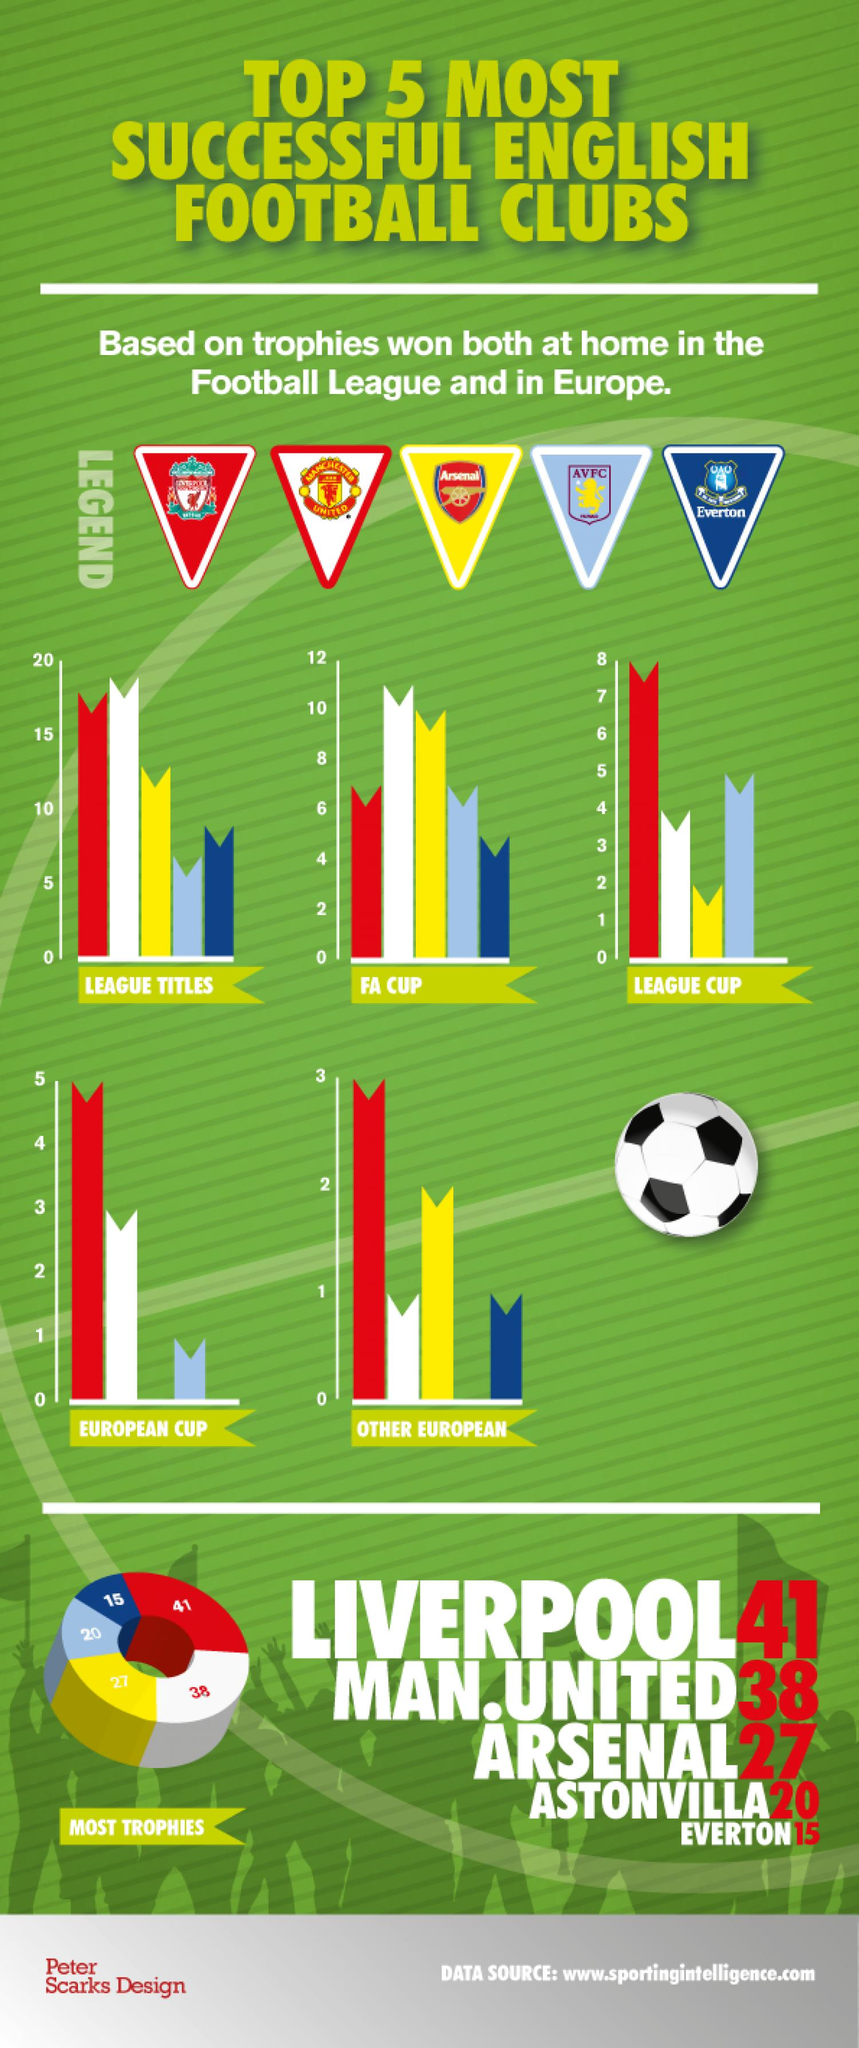Specify some key components in this picture. Manchester United is the football club that has won the highest number of trophies in the FA Cup. Everton FC has won the least number of trophies in the Football Association Cup. Liverpool Football Club has won the highest number of trophies at home in the football league and in Europe. Aston Villa, the football club, has won the second highest number of trophies in the League Cup, as declared. Everton is the football club that has won the least number of trophies at home in both the football league and in Europe. 